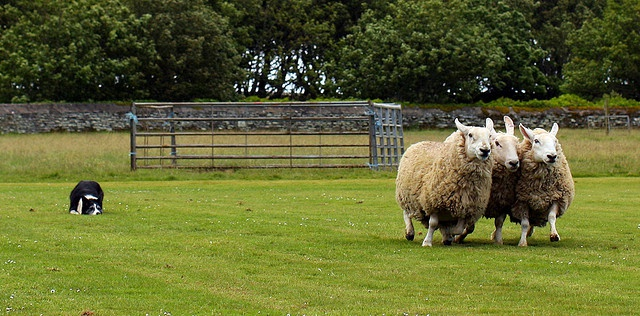Describe the objects in this image and their specific colors. I can see sheep in black, tan, and olive tones, sheep in black, lightgray, olive, and tan tones, sheep in black, lightgray, olive, and tan tones, and dog in black, white, gray, and olive tones in this image. 